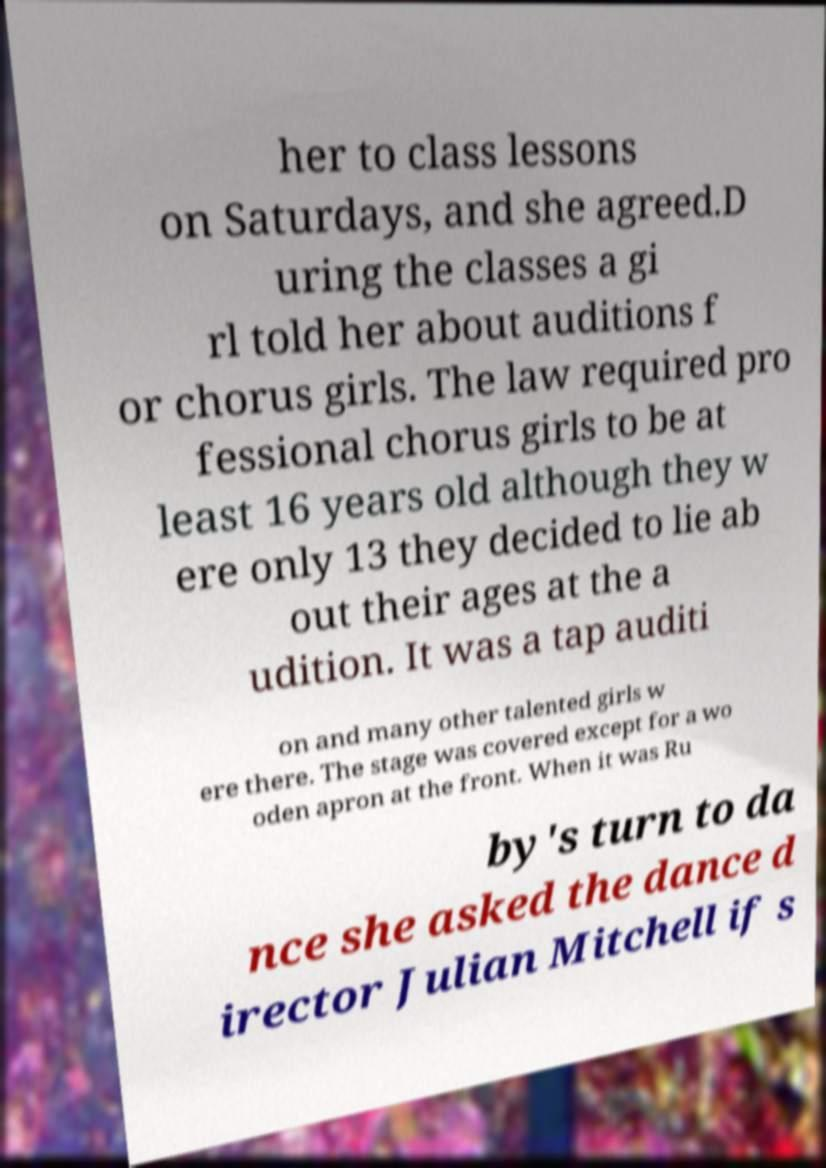For documentation purposes, I need the text within this image transcribed. Could you provide that? her to class lessons on Saturdays, and she agreed.D uring the classes a gi rl told her about auditions f or chorus girls. The law required pro fessional chorus girls to be at least 16 years old although they w ere only 13 they decided to lie ab out their ages at the a udition. It was a tap auditi on and many other talented girls w ere there. The stage was covered except for a wo oden apron at the front. When it was Ru by's turn to da nce she asked the dance d irector Julian Mitchell if s 